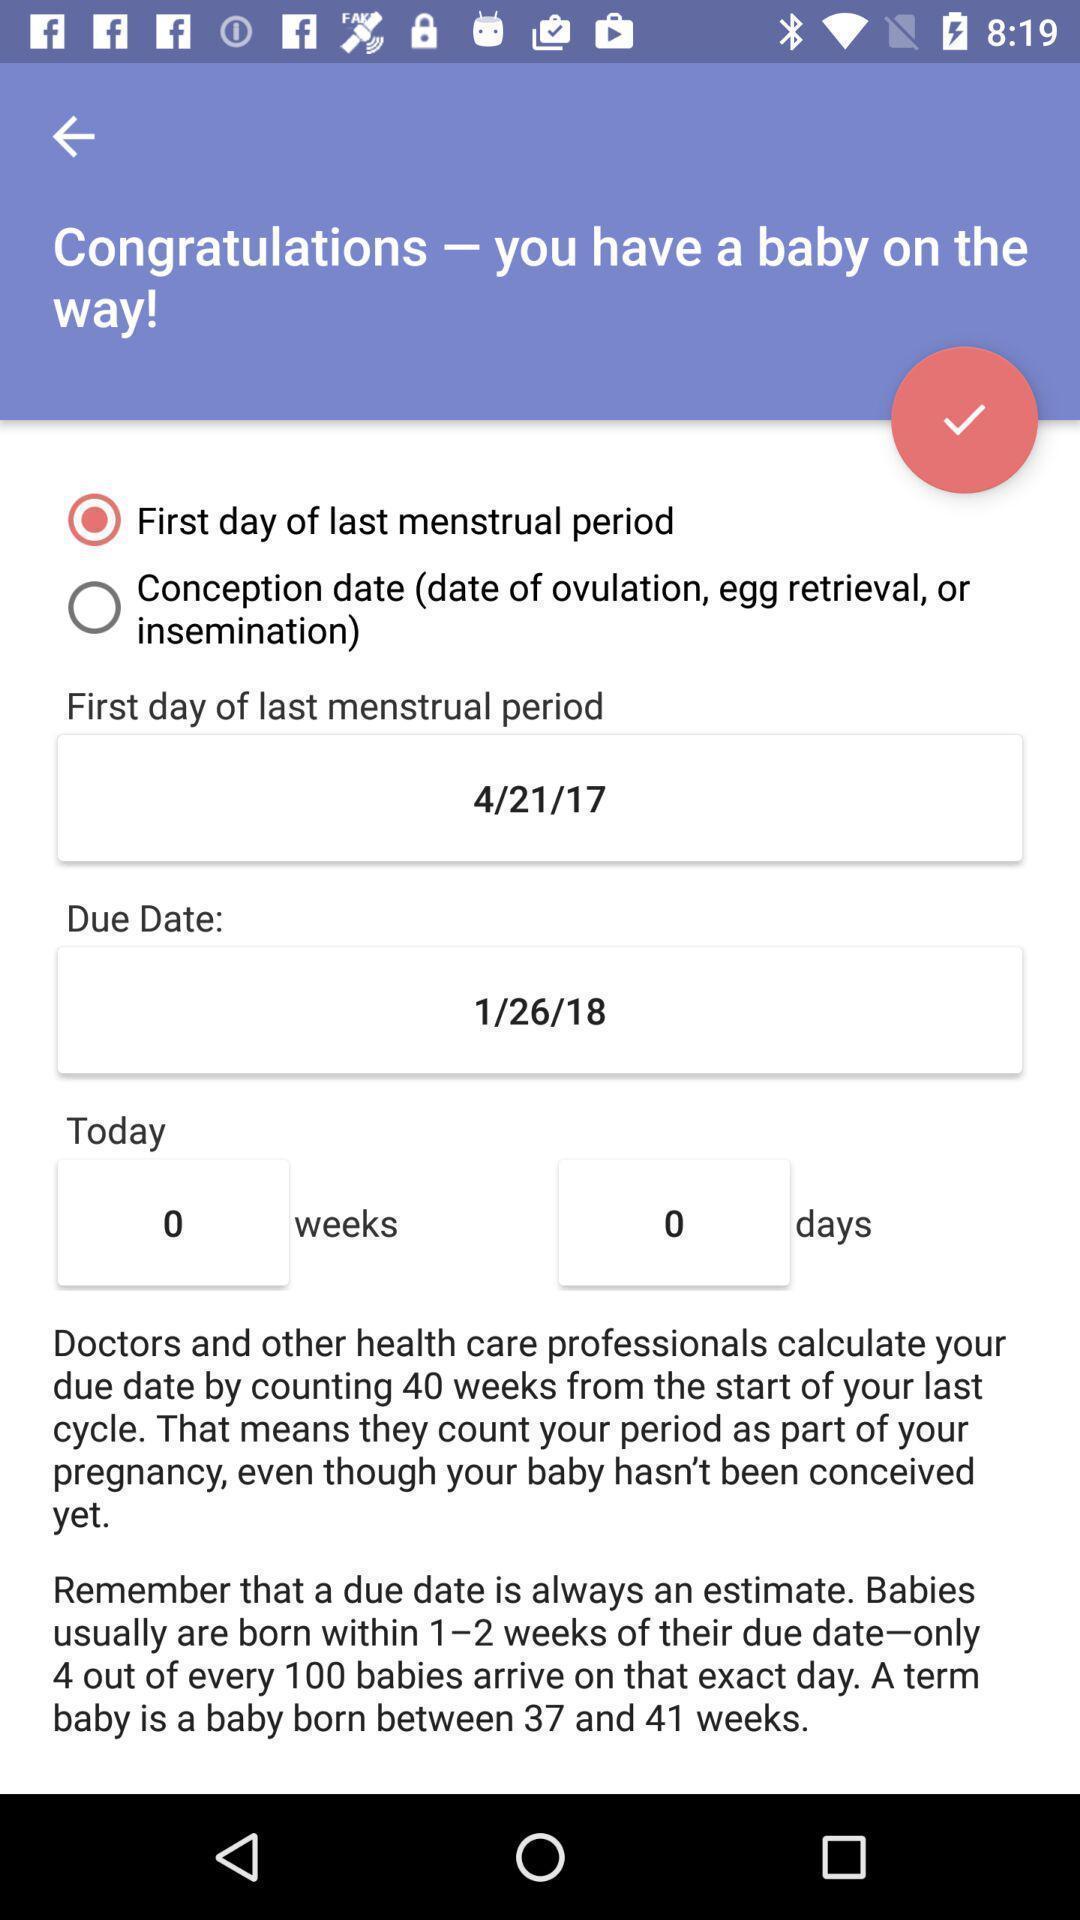Summarize the information in this screenshot. Screen showing reminder for pregnancy in health app. 